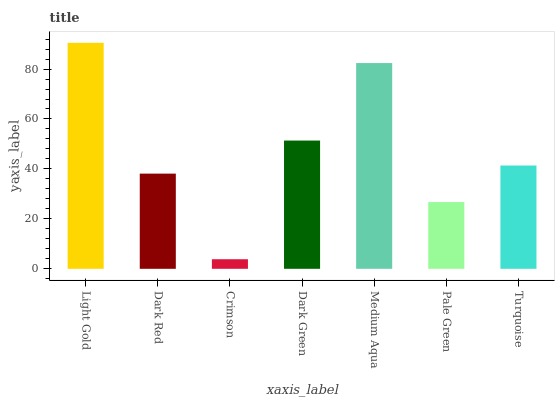Is Crimson the minimum?
Answer yes or no. Yes. Is Light Gold the maximum?
Answer yes or no. Yes. Is Dark Red the minimum?
Answer yes or no. No. Is Dark Red the maximum?
Answer yes or no. No. Is Light Gold greater than Dark Red?
Answer yes or no. Yes. Is Dark Red less than Light Gold?
Answer yes or no. Yes. Is Dark Red greater than Light Gold?
Answer yes or no. No. Is Light Gold less than Dark Red?
Answer yes or no. No. Is Turquoise the high median?
Answer yes or no. Yes. Is Turquoise the low median?
Answer yes or no. Yes. Is Crimson the high median?
Answer yes or no. No. Is Pale Green the low median?
Answer yes or no. No. 